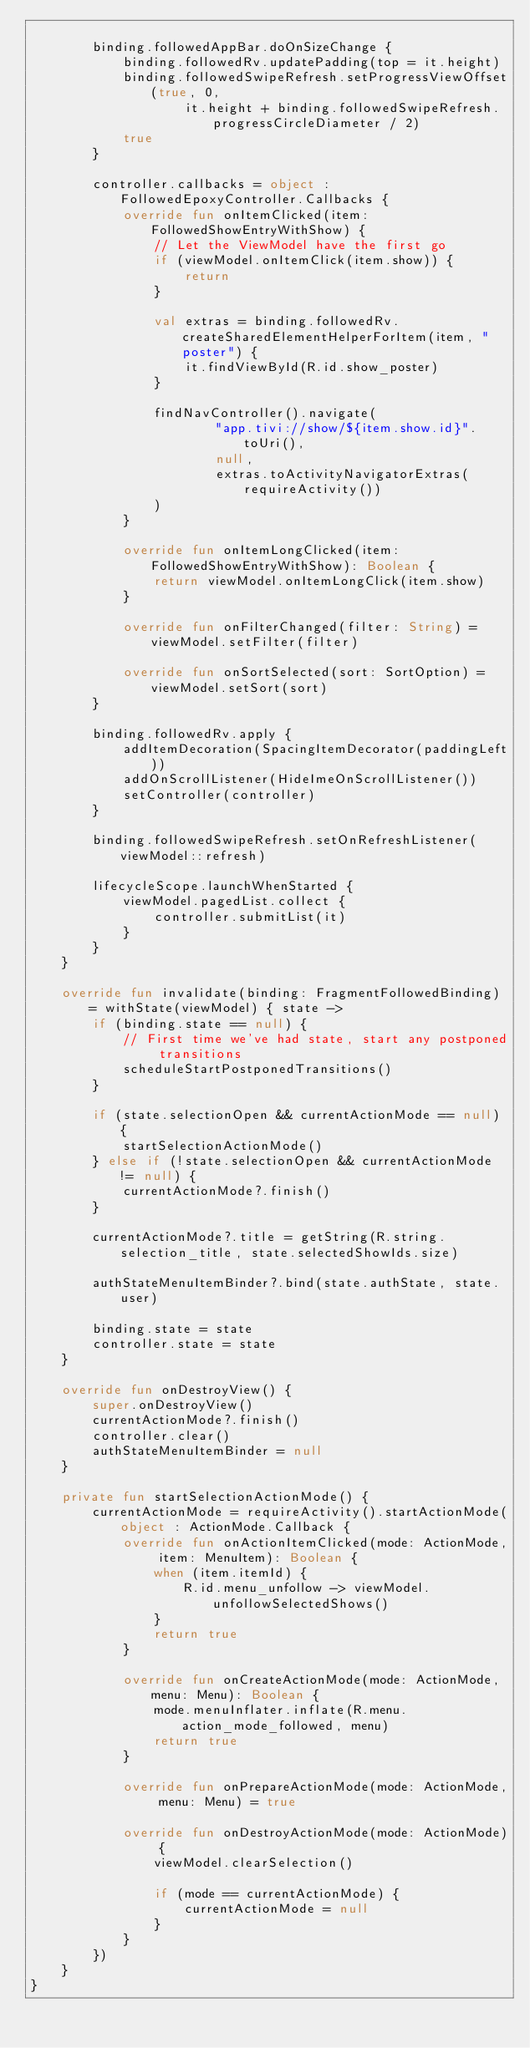<code> <loc_0><loc_0><loc_500><loc_500><_Kotlin_>
        binding.followedAppBar.doOnSizeChange {
            binding.followedRv.updatePadding(top = it.height)
            binding.followedSwipeRefresh.setProgressViewOffset(true, 0,
                    it.height + binding.followedSwipeRefresh.progressCircleDiameter / 2)
            true
        }

        controller.callbacks = object : FollowedEpoxyController.Callbacks {
            override fun onItemClicked(item: FollowedShowEntryWithShow) {
                // Let the ViewModel have the first go
                if (viewModel.onItemClick(item.show)) {
                    return
                }

                val extras = binding.followedRv.createSharedElementHelperForItem(item, "poster") {
                    it.findViewById(R.id.show_poster)
                }

                findNavController().navigate(
                        "app.tivi://show/${item.show.id}".toUri(),
                        null,
                        extras.toActivityNavigatorExtras(requireActivity())
                )
            }

            override fun onItemLongClicked(item: FollowedShowEntryWithShow): Boolean {
                return viewModel.onItemLongClick(item.show)
            }

            override fun onFilterChanged(filter: String) = viewModel.setFilter(filter)

            override fun onSortSelected(sort: SortOption) = viewModel.setSort(sort)
        }

        binding.followedRv.apply {
            addItemDecoration(SpacingItemDecorator(paddingLeft))
            addOnScrollListener(HideImeOnScrollListener())
            setController(controller)
        }

        binding.followedSwipeRefresh.setOnRefreshListener(viewModel::refresh)

        lifecycleScope.launchWhenStarted {
            viewModel.pagedList.collect {
                controller.submitList(it)
            }
        }
    }

    override fun invalidate(binding: FragmentFollowedBinding) = withState(viewModel) { state ->
        if (binding.state == null) {
            // First time we've had state, start any postponed transitions
            scheduleStartPostponedTransitions()
        }

        if (state.selectionOpen && currentActionMode == null) {
            startSelectionActionMode()
        } else if (!state.selectionOpen && currentActionMode != null) {
            currentActionMode?.finish()
        }

        currentActionMode?.title = getString(R.string.selection_title, state.selectedShowIds.size)

        authStateMenuItemBinder?.bind(state.authState, state.user)

        binding.state = state
        controller.state = state
    }

    override fun onDestroyView() {
        super.onDestroyView()
        currentActionMode?.finish()
        controller.clear()
        authStateMenuItemBinder = null
    }

    private fun startSelectionActionMode() {
        currentActionMode = requireActivity().startActionMode(object : ActionMode.Callback {
            override fun onActionItemClicked(mode: ActionMode, item: MenuItem): Boolean {
                when (item.itemId) {
                    R.id.menu_unfollow -> viewModel.unfollowSelectedShows()
                }
                return true
            }

            override fun onCreateActionMode(mode: ActionMode, menu: Menu): Boolean {
                mode.menuInflater.inflate(R.menu.action_mode_followed, menu)
                return true
            }

            override fun onPrepareActionMode(mode: ActionMode, menu: Menu) = true

            override fun onDestroyActionMode(mode: ActionMode) {
                viewModel.clearSelection()

                if (mode == currentActionMode) {
                    currentActionMode = null
                }
            }
        })
    }
}
</code> 